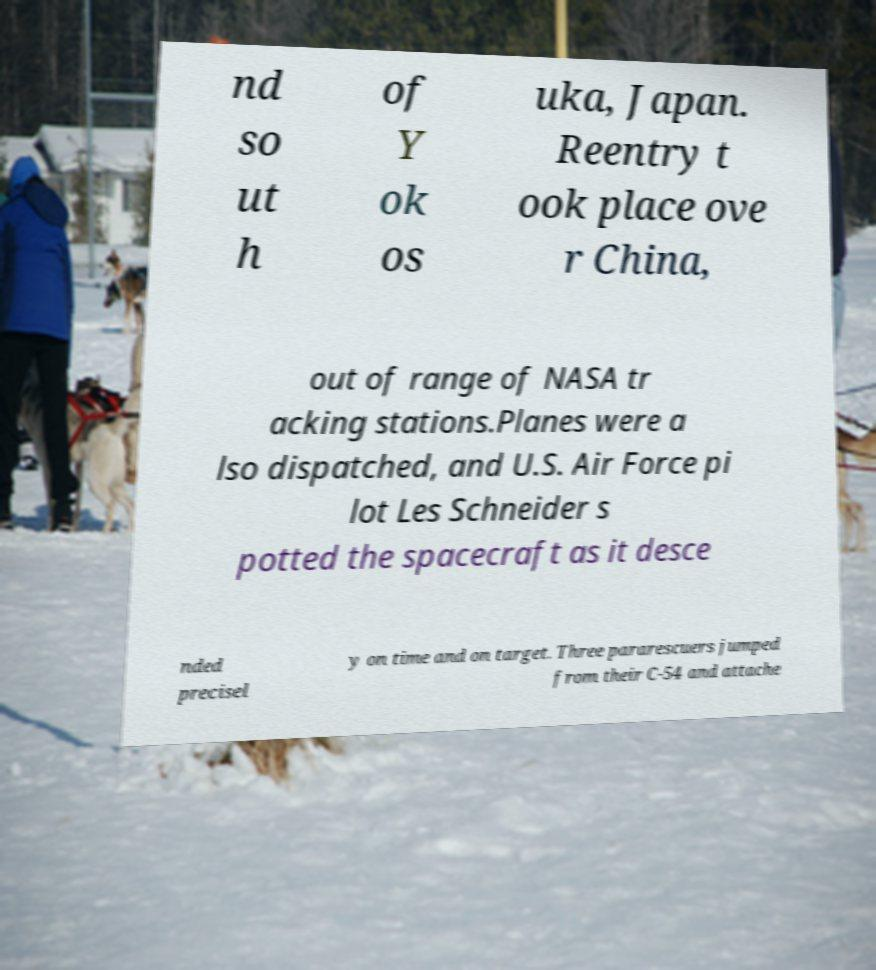Could you assist in decoding the text presented in this image and type it out clearly? nd so ut h of Y ok os uka, Japan. Reentry t ook place ove r China, out of range of NASA tr acking stations.Planes were a lso dispatched, and U.S. Air Force pi lot Les Schneider s potted the spacecraft as it desce nded precisel y on time and on target. Three pararescuers jumped from their C-54 and attache 